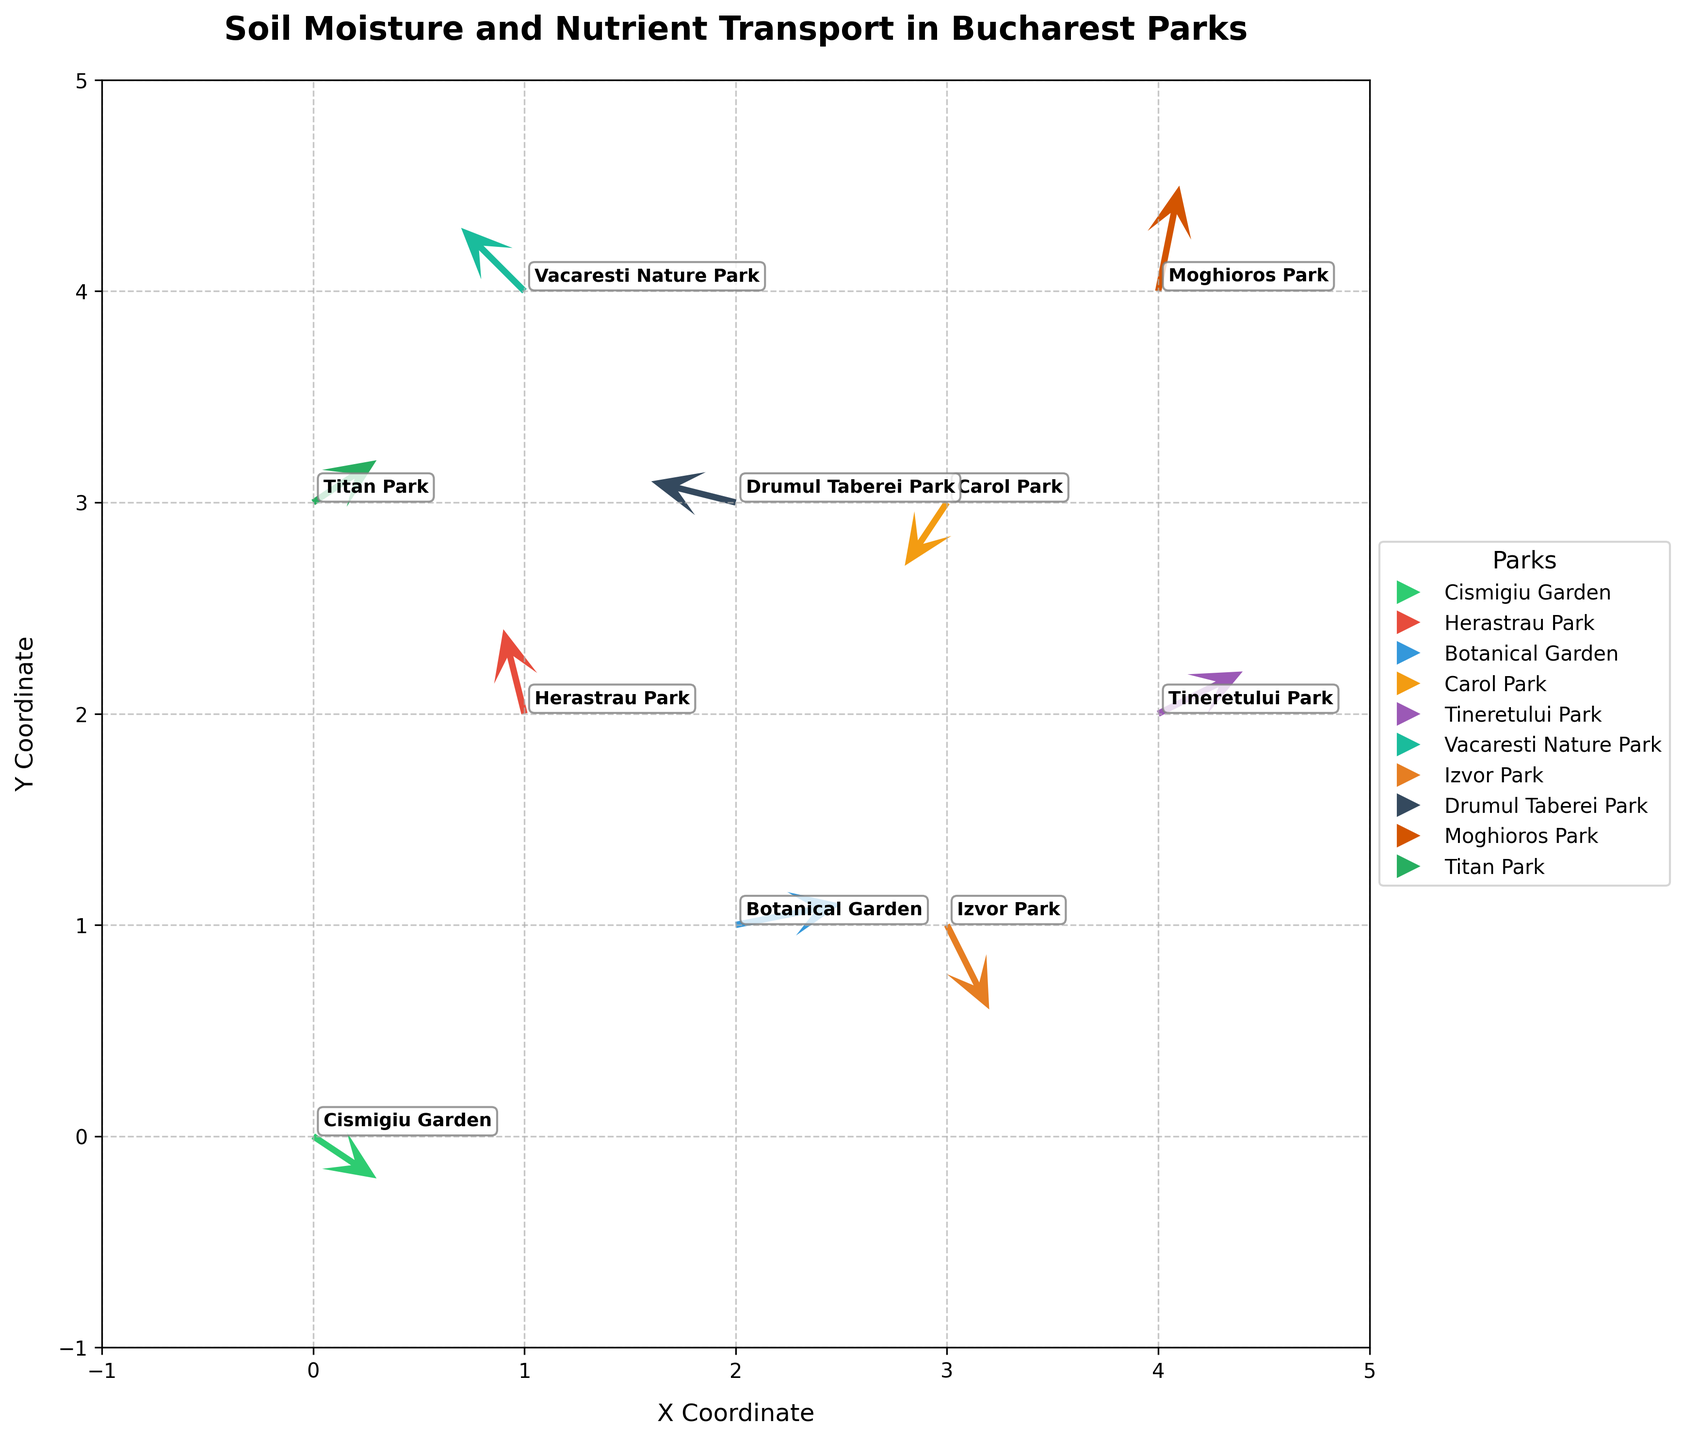How many parks are represented in the plot? By counting the unique locations mentioned in the figure, we can see that there are 10 parks represented by the quivers.
Answer: 10 What is the general direction of vector for Herastrau Park? We can look at the direction of the arrow for Herastrau Park, which points primarily up and slightly to the left. This indicates a general direction that's upward and slightly leftward.
Answer: Upward and slightly leftward Which park has the longest vector in the plot? To determine the longest vector, we visually compare the length of each arrow. The longest arrow seems to be the one at Moghioros Park.
Answer: Moghioros Park What are the X and Y coordinates for Vacaresti Nature Park? We can read the coordinates next to the annotated name "Vacaresti Nature Park". The coordinates are (1, 4).
Answer: (1, 4) In which park is soil moisture moving primarily to the left? By inspecting the direction of arrows, we find Drumul Taberei Park's vector is primarily pointing left (negative x-direction).
Answer: Drumul Taberei Park Which parks exhibit downward soil moisture transport? Name all of them. We examine the arrows pointing downward in the plot. Both Cismigiu Garden and Izvor Park have vectors pointing downward.
Answer: Cismigiu Garden and Izvor Park Compare the vectors in Botanical Garden and Tineretului Park. Which one shows greater soil nutrient transport in the x-direction? By comparing the length of the arrows along the x-axis, the arrow for Botanical Garden shows a greater component in the x-direction than Tineretului Park.
Answer: Botanical Garden What is the average y-coordinate of all parks? We sum up all y-coordinates: (0 + 2 + 1 + 3 + 2 + 4 + 1 + 3 + 4 + 3) = 23, and divide by the number of data points: 23 / 10 = 2.3.
Answer: 2.3 Which park shows the vector with negative y and positive x directions? We identify the vectors (arrows) for parks with these properties, and find that Tineretului Park's vector points in these directions.
Answer: Tineretului Park 